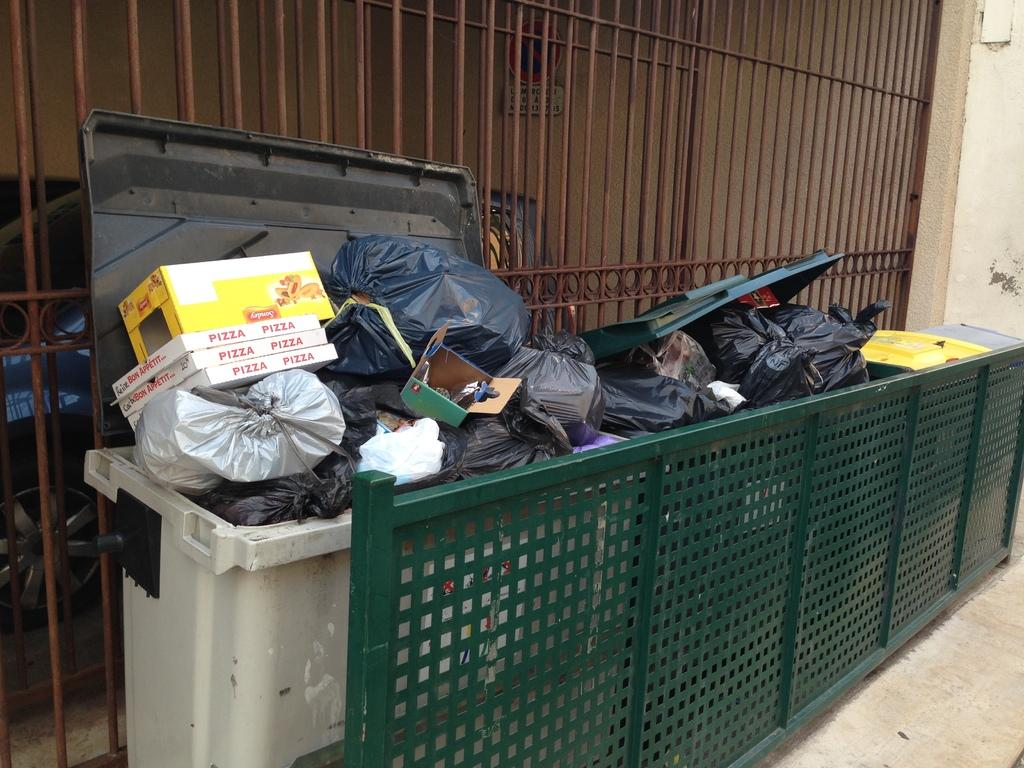<image>
Provide a brief description of the given image. Three boxes that say "pizza" on them are stacked in a dumpster. 